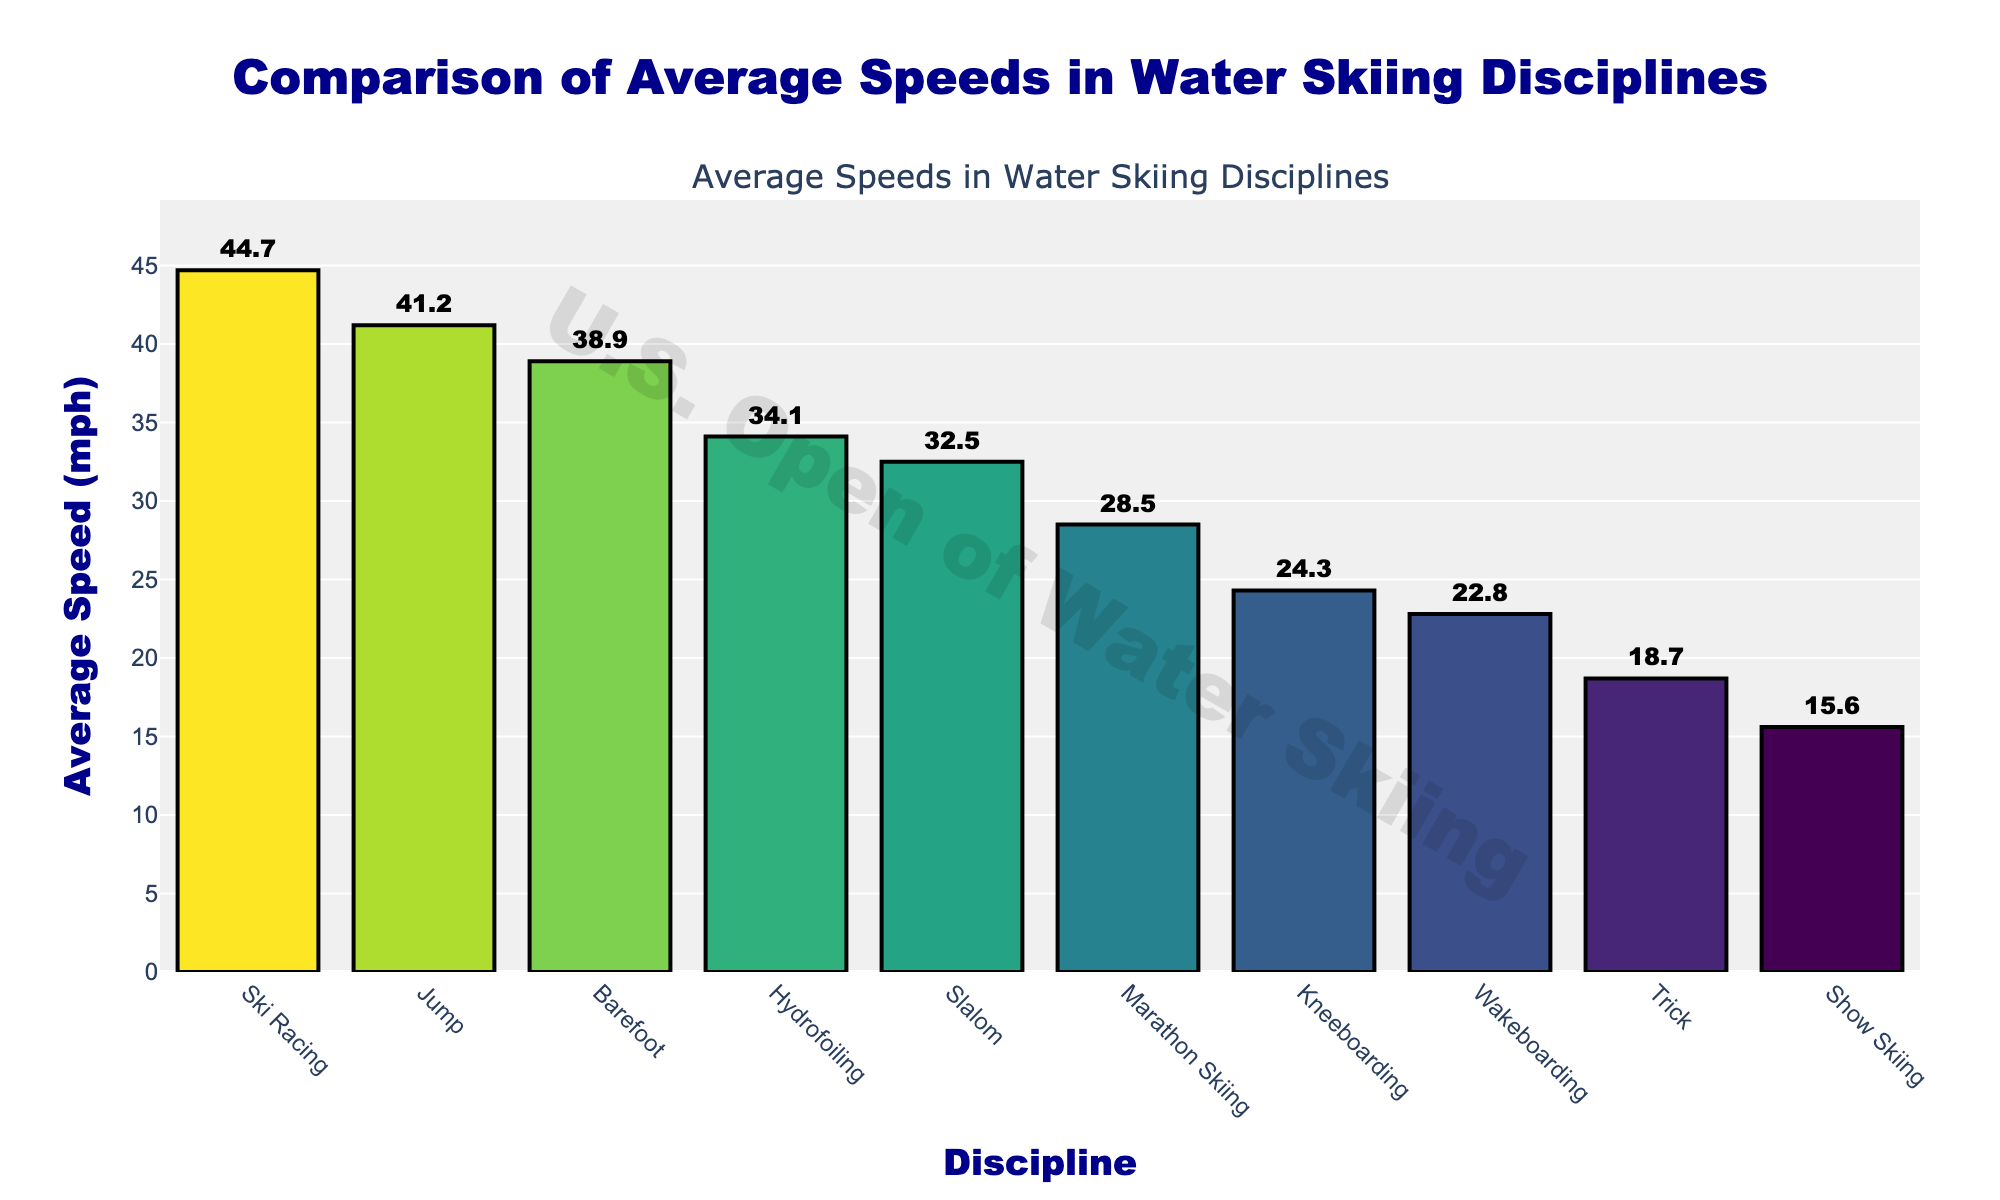What's the discipline with the highest average speed? Look at the bar that reaches the highest value on the y-axis. The label corresponds to the discipline with the highest average speed.
Answer: Ski Racing What is the difference in average speed between Slalom and Trick? Subtract the average speed of Trick from the average speed of Slalom (32.5 - 18.7).
Answer: 13.8 mph Which discipline has a higher average speed, Barefoot or Kneeboarding? Compare the heights of the bars for Barefoot and Kneeboarding. The taller bar corresponds to the discipline with the higher average speed.
Answer: Barefoot How many disciplines have an average speed above 30 mph? Count the bars that extend above the 30 mph mark on the y-axis.
Answer: 5 What is the sum of the average speeds of Trick, Show Skiing, and Wakeboarding? Add the average speeds of Trick (18.7), Show Skiing (15.6), and Wakeboarding (22.8). (18.7 + 15.6 + 22.8)
Answer: 57.1 mph Which has a lower average speed, Hydrofoiling or Marathon Skiing? Compare the heights of the bars for Hydrofoiling and Marathon Skiing. The shorter bar corresponds to the discipline with the lower average speed.
Answer: Marathon Skiing What’s the average of the top three fastest disciplines? Identify the top three disciplines by speed (Ski Racing, Jump, and Barefoot), then calculate their average speed. ((44.7 + 41.2 + 38.9) / 3)
Answer: 41.6 mph Is the average speed of Kneeboarding closer to the average speed of Show Skiing or Wakeboarding? Compare the difference between the average speed of Kneeboarding (24.3) with Show Skiing (15.6) and Wakeboarding (22.8). The smallest difference indicates the closer average speed. (24.3 - 15.6 = 8.7; 24.3 - 22.8 = 1.5)
Answer: Wakeboarding 